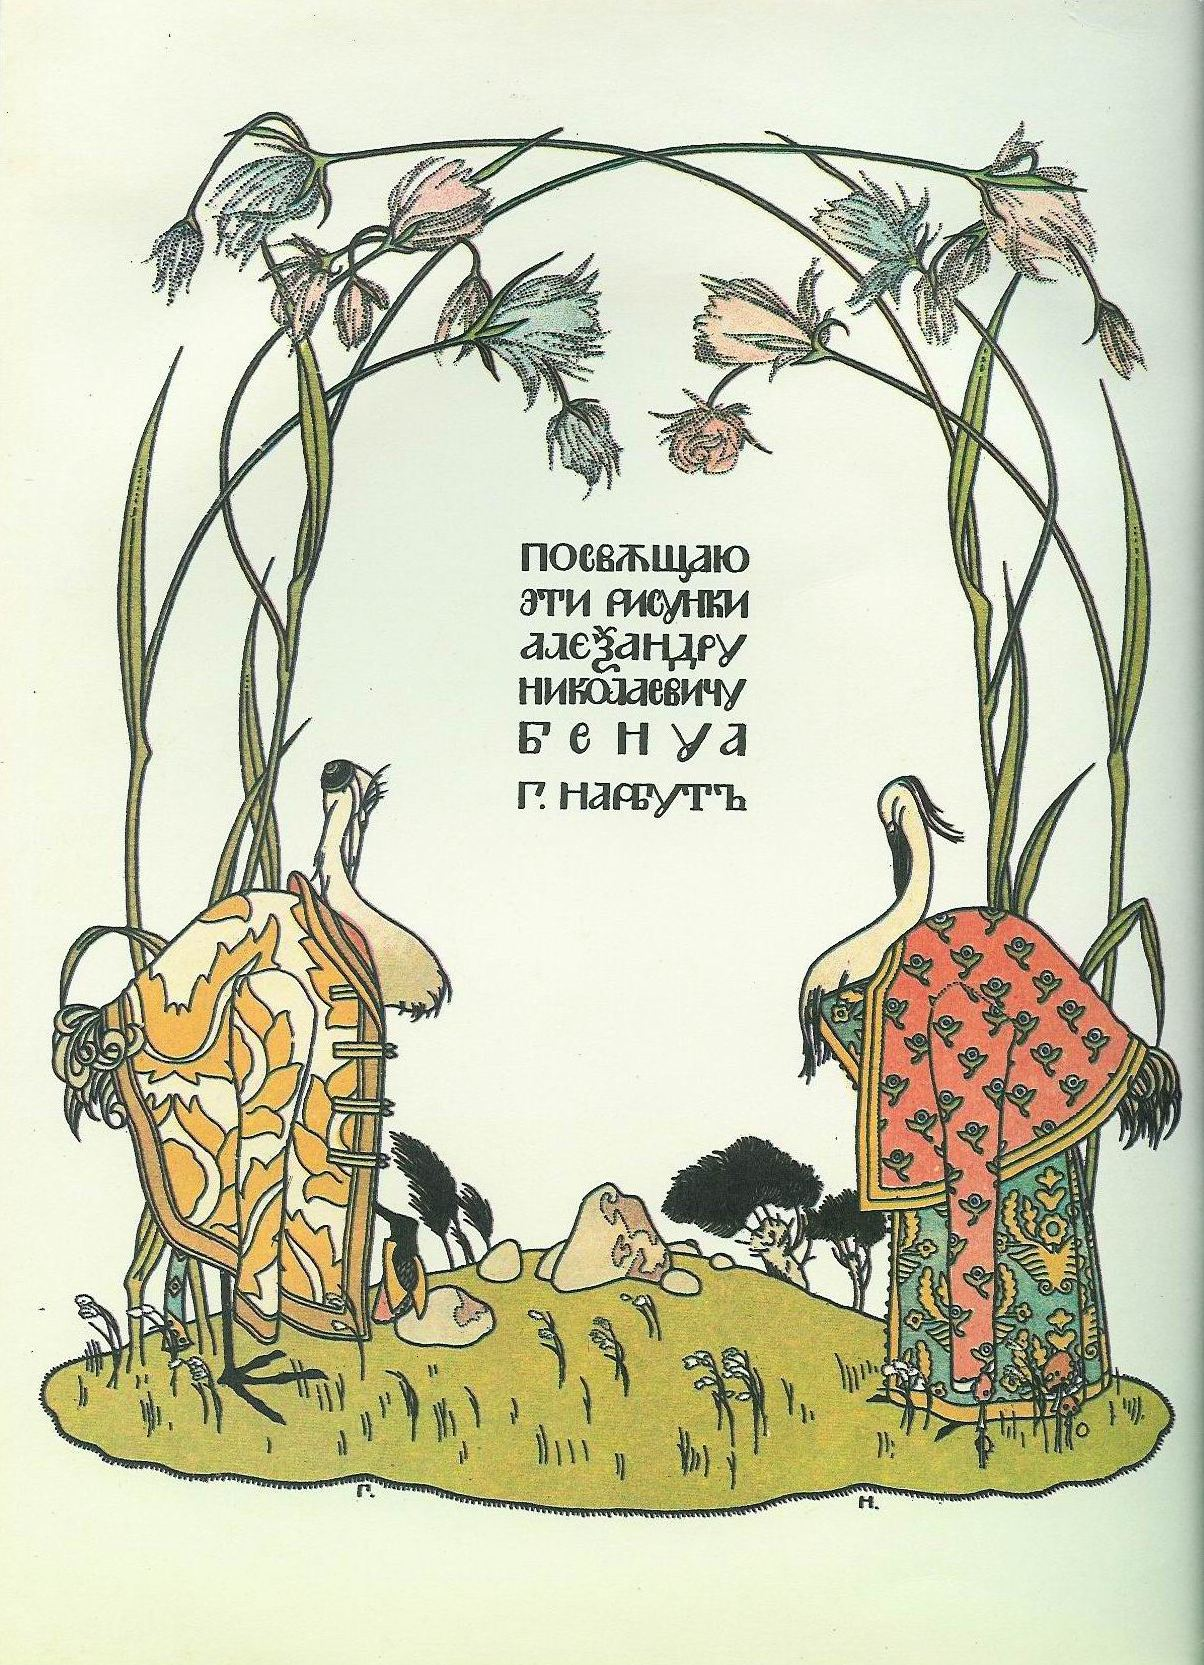What time period does this image likely represent? This image likely represents a late 19th to early 20th century artistic trend, specifically the Art Nouveau movement. This period was characterized by its emphasis on organic forms, intricate decorative patterns, and an overall aesthetic that celebrated natural beauty and fluid lines. Why are the storks dressed in such elaborate garments? The storks dressed in elaborate garments are a whimsical touch that adds to the fairy tale ambiance of the image. In many folk tales and artistic interpretations, animals are often anthropomorphized, given human characteristics or roles to convey deeper meanings or to symbolize certain traits. Here, the dressed storks may symbolize guardianship, wisdom, or a connection between the natural and human worlds, creating an enchanting and otherworldly atmosphere. Can you create a story based on this image? Once upon a time, in a quaint village nestled at the edge of a vast forest, stood two peculiar houses unlike any other. These houses belonged to two storks, Sir Featherington and Lady Plummewing, who were no ordinary birds. Each dawn, they dressed in their elaborate, handwoven garments—symbols of their ancient lineage and wisdom. Underneath a magical archway intertwined with blossoms, they tended to their garden of dreams, where each flower held a wish from the villagers. One serene morning, as the pale green light bathed the land, a young girl named Elara visited their garden, seeking a blessing for her family. Guided by the soft rustle of petals and leaves, her journey into the enchanted realm led her to discover secrets of the universe, bridging the mortal and magical worlds... 